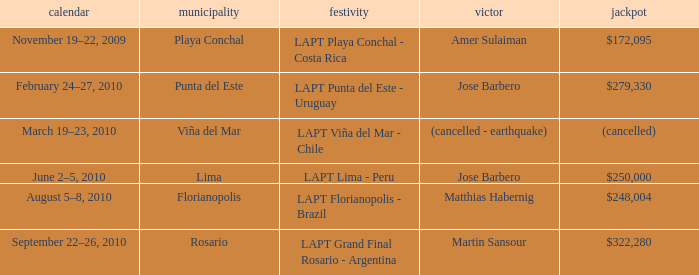Who is the winner in the city of lima? Jose Barbero. 